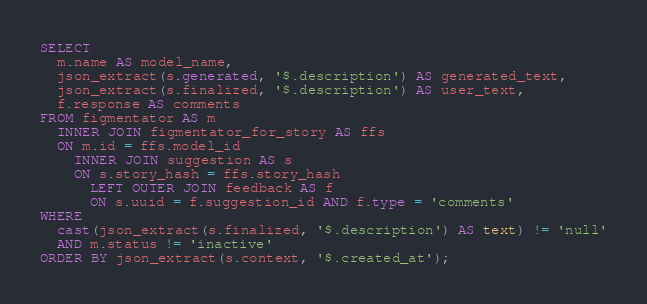Convert code to text. <code><loc_0><loc_0><loc_500><loc_500><_SQL_>SELECT
  m.name AS model_name,
  json_extract(s.generated, '$.description') AS generated_text,
  json_extract(s.finalized, '$.description') AS user_text,
  f.response AS comments
FROM figmentator AS m
  INNER JOIN figmentator_for_story AS ffs
  ON m.id = ffs.model_id
    INNER JOIN suggestion AS s
    ON s.story_hash = ffs.story_hash
      LEFT OUTER JOIN feedback AS f
      ON s.uuid = f.suggestion_id AND f.type = 'comments'
WHERE
  cast(json_extract(s.finalized, '$.description') AS text) != 'null'
  AND m.status != 'inactive'
ORDER BY json_extract(s.context, '$.created_at');
</code> 